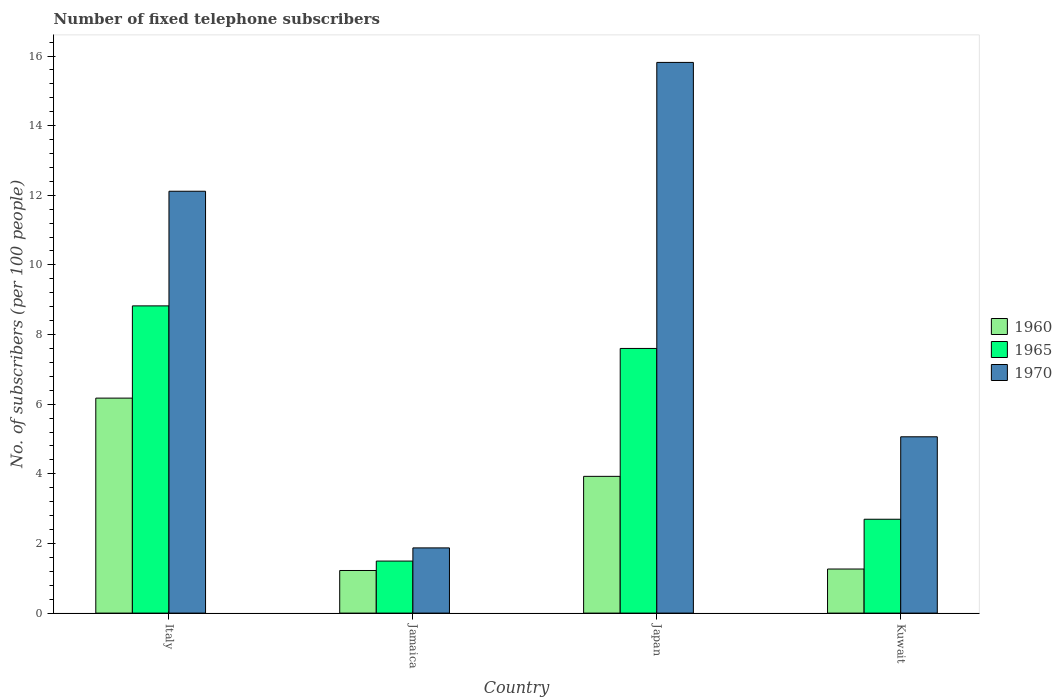How many different coloured bars are there?
Offer a very short reply. 3. How many groups of bars are there?
Give a very brief answer. 4. Are the number of bars per tick equal to the number of legend labels?
Offer a terse response. Yes. Are the number of bars on each tick of the X-axis equal?
Offer a terse response. Yes. How many bars are there on the 2nd tick from the right?
Offer a terse response. 3. What is the label of the 2nd group of bars from the left?
Make the answer very short. Jamaica. In how many cases, is the number of bars for a given country not equal to the number of legend labels?
Provide a succinct answer. 0. What is the number of fixed telephone subscribers in 1965 in Jamaica?
Keep it short and to the point. 1.49. Across all countries, what is the maximum number of fixed telephone subscribers in 1960?
Your answer should be compact. 6.17. Across all countries, what is the minimum number of fixed telephone subscribers in 1960?
Provide a succinct answer. 1.22. In which country was the number of fixed telephone subscribers in 1970 minimum?
Your response must be concise. Jamaica. What is the total number of fixed telephone subscribers in 1965 in the graph?
Offer a terse response. 20.61. What is the difference between the number of fixed telephone subscribers in 1970 in Jamaica and that in Kuwait?
Offer a very short reply. -3.19. What is the difference between the number of fixed telephone subscribers in 1965 in Kuwait and the number of fixed telephone subscribers in 1960 in Japan?
Make the answer very short. -1.23. What is the average number of fixed telephone subscribers in 1965 per country?
Your response must be concise. 5.15. What is the difference between the number of fixed telephone subscribers of/in 1960 and number of fixed telephone subscribers of/in 1965 in Jamaica?
Give a very brief answer. -0.27. In how many countries, is the number of fixed telephone subscribers in 1960 greater than 2.4?
Offer a terse response. 2. What is the ratio of the number of fixed telephone subscribers in 1965 in Italy to that in Jamaica?
Provide a succinct answer. 5.91. Is the number of fixed telephone subscribers in 1970 in Italy less than that in Kuwait?
Your response must be concise. No. What is the difference between the highest and the second highest number of fixed telephone subscribers in 1965?
Ensure brevity in your answer.  6.13. What is the difference between the highest and the lowest number of fixed telephone subscribers in 1970?
Your response must be concise. 13.94. In how many countries, is the number of fixed telephone subscribers in 1965 greater than the average number of fixed telephone subscribers in 1965 taken over all countries?
Ensure brevity in your answer.  2. Is the sum of the number of fixed telephone subscribers in 1965 in Jamaica and Kuwait greater than the maximum number of fixed telephone subscribers in 1970 across all countries?
Your answer should be very brief. No. What does the 3rd bar from the left in Jamaica represents?
Your answer should be compact. 1970. Is it the case that in every country, the sum of the number of fixed telephone subscribers in 1970 and number of fixed telephone subscribers in 1960 is greater than the number of fixed telephone subscribers in 1965?
Offer a very short reply. Yes. How many bars are there?
Make the answer very short. 12. How many countries are there in the graph?
Offer a very short reply. 4. What is the difference between two consecutive major ticks on the Y-axis?
Give a very brief answer. 2. Are the values on the major ticks of Y-axis written in scientific E-notation?
Provide a succinct answer. No. Does the graph contain any zero values?
Your answer should be very brief. No. How many legend labels are there?
Your answer should be very brief. 3. What is the title of the graph?
Your answer should be compact. Number of fixed telephone subscribers. Does "1960" appear as one of the legend labels in the graph?
Provide a succinct answer. Yes. What is the label or title of the X-axis?
Provide a short and direct response. Country. What is the label or title of the Y-axis?
Make the answer very short. No. of subscribers (per 100 people). What is the No. of subscribers (per 100 people) of 1960 in Italy?
Your answer should be very brief. 6.17. What is the No. of subscribers (per 100 people) of 1965 in Italy?
Offer a very short reply. 8.82. What is the No. of subscribers (per 100 people) in 1970 in Italy?
Your answer should be compact. 12.12. What is the No. of subscribers (per 100 people) of 1960 in Jamaica?
Offer a very short reply. 1.22. What is the No. of subscribers (per 100 people) of 1965 in Jamaica?
Keep it short and to the point. 1.49. What is the No. of subscribers (per 100 people) of 1970 in Jamaica?
Offer a very short reply. 1.87. What is the No. of subscribers (per 100 people) in 1960 in Japan?
Make the answer very short. 3.93. What is the No. of subscribers (per 100 people) of 1965 in Japan?
Offer a terse response. 7.6. What is the No. of subscribers (per 100 people) in 1970 in Japan?
Your response must be concise. 15.82. What is the No. of subscribers (per 100 people) in 1960 in Kuwait?
Keep it short and to the point. 1.27. What is the No. of subscribers (per 100 people) in 1965 in Kuwait?
Make the answer very short. 2.7. What is the No. of subscribers (per 100 people) in 1970 in Kuwait?
Provide a short and direct response. 5.06. Across all countries, what is the maximum No. of subscribers (per 100 people) in 1960?
Keep it short and to the point. 6.17. Across all countries, what is the maximum No. of subscribers (per 100 people) in 1965?
Your answer should be very brief. 8.82. Across all countries, what is the maximum No. of subscribers (per 100 people) in 1970?
Offer a terse response. 15.82. Across all countries, what is the minimum No. of subscribers (per 100 people) of 1960?
Provide a short and direct response. 1.22. Across all countries, what is the minimum No. of subscribers (per 100 people) of 1965?
Provide a succinct answer. 1.49. Across all countries, what is the minimum No. of subscribers (per 100 people) of 1970?
Provide a succinct answer. 1.87. What is the total No. of subscribers (per 100 people) in 1960 in the graph?
Ensure brevity in your answer.  12.59. What is the total No. of subscribers (per 100 people) of 1965 in the graph?
Give a very brief answer. 20.61. What is the total No. of subscribers (per 100 people) of 1970 in the graph?
Keep it short and to the point. 34.87. What is the difference between the No. of subscribers (per 100 people) in 1960 in Italy and that in Jamaica?
Offer a terse response. 4.95. What is the difference between the No. of subscribers (per 100 people) in 1965 in Italy and that in Jamaica?
Keep it short and to the point. 7.33. What is the difference between the No. of subscribers (per 100 people) in 1970 in Italy and that in Jamaica?
Offer a very short reply. 10.24. What is the difference between the No. of subscribers (per 100 people) in 1960 in Italy and that in Japan?
Provide a succinct answer. 2.25. What is the difference between the No. of subscribers (per 100 people) of 1965 in Italy and that in Japan?
Ensure brevity in your answer.  1.22. What is the difference between the No. of subscribers (per 100 people) of 1970 in Italy and that in Japan?
Offer a terse response. -3.7. What is the difference between the No. of subscribers (per 100 people) in 1960 in Italy and that in Kuwait?
Offer a very short reply. 4.91. What is the difference between the No. of subscribers (per 100 people) of 1965 in Italy and that in Kuwait?
Your response must be concise. 6.13. What is the difference between the No. of subscribers (per 100 people) in 1970 in Italy and that in Kuwait?
Your answer should be compact. 7.05. What is the difference between the No. of subscribers (per 100 people) in 1960 in Jamaica and that in Japan?
Ensure brevity in your answer.  -2.7. What is the difference between the No. of subscribers (per 100 people) of 1965 in Jamaica and that in Japan?
Give a very brief answer. -6.11. What is the difference between the No. of subscribers (per 100 people) in 1970 in Jamaica and that in Japan?
Your answer should be compact. -13.94. What is the difference between the No. of subscribers (per 100 people) of 1960 in Jamaica and that in Kuwait?
Your response must be concise. -0.04. What is the difference between the No. of subscribers (per 100 people) of 1965 in Jamaica and that in Kuwait?
Provide a short and direct response. -1.2. What is the difference between the No. of subscribers (per 100 people) in 1970 in Jamaica and that in Kuwait?
Give a very brief answer. -3.19. What is the difference between the No. of subscribers (per 100 people) of 1960 in Japan and that in Kuwait?
Keep it short and to the point. 2.66. What is the difference between the No. of subscribers (per 100 people) of 1965 in Japan and that in Kuwait?
Provide a succinct answer. 4.91. What is the difference between the No. of subscribers (per 100 people) of 1970 in Japan and that in Kuwait?
Your answer should be compact. 10.75. What is the difference between the No. of subscribers (per 100 people) of 1960 in Italy and the No. of subscribers (per 100 people) of 1965 in Jamaica?
Keep it short and to the point. 4.68. What is the difference between the No. of subscribers (per 100 people) in 1960 in Italy and the No. of subscribers (per 100 people) in 1970 in Jamaica?
Provide a short and direct response. 4.3. What is the difference between the No. of subscribers (per 100 people) in 1965 in Italy and the No. of subscribers (per 100 people) in 1970 in Jamaica?
Your answer should be very brief. 6.95. What is the difference between the No. of subscribers (per 100 people) of 1960 in Italy and the No. of subscribers (per 100 people) of 1965 in Japan?
Your answer should be compact. -1.43. What is the difference between the No. of subscribers (per 100 people) in 1960 in Italy and the No. of subscribers (per 100 people) in 1970 in Japan?
Your answer should be compact. -9.64. What is the difference between the No. of subscribers (per 100 people) in 1965 in Italy and the No. of subscribers (per 100 people) in 1970 in Japan?
Keep it short and to the point. -6.99. What is the difference between the No. of subscribers (per 100 people) in 1960 in Italy and the No. of subscribers (per 100 people) in 1965 in Kuwait?
Ensure brevity in your answer.  3.48. What is the difference between the No. of subscribers (per 100 people) in 1960 in Italy and the No. of subscribers (per 100 people) in 1970 in Kuwait?
Provide a short and direct response. 1.11. What is the difference between the No. of subscribers (per 100 people) of 1965 in Italy and the No. of subscribers (per 100 people) of 1970 in Kuwait?
Your answer should be very brief. 3.76. What is the difference between the No. of subscribers (per 100 people) of 1960 in Jamaica and the No. of subscribers (per 100 people) of 1965 in Japan?
Your response must be concise. -6.38. What is the difference between the No. of subscribers (per 100 people) in 1960 in Jamaica and the No. of subscribers (per 100 people) in 1970 in Japan?
Offer a very short reply. -14.59. What is the difference between the No. of subscribers (per 100 people) of 1965 in Jamaica and the No. of subscribers (per 100 people) of 1970 in Japan?
Your answer should be very brief. -14.32. What is the difference between the No. of subscribers (per 100 people) in 1960 in Jamaica and the No. of subscribers (per 100 people) in 1965 in Kuwait?
Give a very brief answer. -1.47. What is the difference between the No. of subscribers (per 100 people) of 1960 in Jamaica and the No. of subscribers (per 100 people) of 1970 in Kuwait?
Your answer should be very brief. -3.84. What is the difference between the No. of subscribers (per 100 people) of 1965 in Jamaica and the No. of subscribers (per 100 people) of 1970 in Kuwait?
Keep it short and to the point. -3.57. What is the difference between the No. of subscribers (per 100 people) of 1960 in Japan and the No. of subscribers (per 100 people) of 1965 in Kuwait?
Offer a terse response. 1.23. What is the difference between the No. of subscribers (per 100 people) in 1960 in Japan and the No. of subscribers (per 100 people) in 1970 in Kuwait?
Provide a short and direct response. -1.14. What is the difference between the No. of subscribers (per 100 people) of 1965 in Japan and the No. of subscribers (per 100 people) of 1970 in Kuwait?
Your answer should be very brief. 2.54. What is the average No. of subscribers (per 100 people) in 1960 per country?
Ensure brevity in your answer.  3.15. What is the average No. of subscribers (per 100 people) in 1965 per country?
Your response must be concise. 5.15. What is the average No. of subscribers (per 100 people) in 1970 per country?
Ensure brevity in your answer.  8.72. What is the difference between the No. of subscribers (per 100 people) in 1960 and No. of subscribers (per 100 people) in 1965 in Italy?
Offer a very short reply. -2.65. What is the difference between the No. of subscribers (per 100 people) in 1960 and No. of subscribers (per 100 people) in 1970 in Italy?
Your answer should be very brief. -5.94. What is the difference between the No. of subscribers (per 100 people) of 1965 and No. of subscribers (per 100 people) of 1970 in Italy?
Keep it short and to the point. -3.29. What is the difference between the No. of subscribers (per 100 people) of 1960 and No. of subscribers (per 100 people) of 1965 in Jamaica?
Give a very brief answer. -0.27. What is the difference between the No. of subscribers (per 100 people) of 1960 and No. of subscribers (per 100 people) of 1970 in Jamaica?
Offer a very short reply. -0.65. What is the difference between the No. of subscribers (per 100 people) of 1965 and No. of subscribers (per 100 people) of 1970 in Jamaica?
Offer a terse response. -0.38. What is the difference between the No. of subscribers (per 100 people) of 1960 and No. of subscribers (per 100 people) of 1965 in Japan?
Your answer should be compact. -3.67. What is the difference between the No. of subscribers (per 100 people) in 1960 and No. of subscribers (per 100 people) in 1970 in Japan?
Keep it short and to the point. -11.89. What is the difference between the No. of subscribers (per 100 people) in 1965 and No. of subscribers (per 100 people) in 1970 in Japan?
Your answer should be very brief. -8.22. What is the difference between the No. of subscribers (per 100 people) in 1960 and No. of subscribers (per 100 people) in 1965 in Kuwait?
Ensure brevity in your answer.  -1.43. What is the difference between the No. of subscribers (per 100 people) of 1960 and No. of subscribers (per 100 people) of 1970 in Kuwait?
Provide a succinct answer. -3.8. What is the difference between the No. of subscribers (per 100 people) in 1965 and No. of subscribers (per 100 people) in 1970 in Kuwait?
Provide a short and direct response. -2.37. What is the ratio of the No. of subscribers (per 100 people) in 1960 in Italy to that in Jamaica?
Make the answer very short. 5.05. What is the ratio of the No. of subscribers (per 100 people) in 1965 in Italy to that in Jamaica?
Make the answer very short. 5.91. What is the ratio of the No. of subscribers (per 100 people) of 1970 in Italy to that in Jamaica?
Provide a succinct answer. 6.47. What is the ratio of the No. of subscribers (per 100 people) in 1960 in Italy to that in Japan?
Give a very brief answer. 1.57. What is the ratio of the No. of subscribers (per 100 people) in 1965 in Italy to that in Japan?
Provide a succinct answer. 1.16. What is the ratio of the No. of subscribers (per 100 people) of 1970 in Italy to that in Japan?
Your answer should be very brief. 0.77. What is the ratio of the No. of subscribers (per 100 people) of 1960 in Italy to that in Kuwait?
Your answer should be compact. 4.88. What is the ratio of the No. of subscribers (per 100 people) in 1965 in Italy to that in Kuwait?
Your response must be concise. 3.27. What is the ratio of the No. of subscribers (per 100 people) in 1970 in Italy to that in Kuwait?
Provide a short and direct response. 2.39. What is the ratio of the No. of subscribers (per 100 people) of 1960 in Jamaica to that in Japan?
Offer a terse response. 0.31. What is the ratio of the No. of subscribers (per 100 people) of 1965 in Jamaica to that in Japan?
Provide a succinct answer. 0.2. What is the ratio of the No. of subscribers (per 100 people) in 1970 in Jamaica to that in Japan?
Your answer should be very brief. 0.12. What is the ratio of the No. of subscribers (per 100 people) in 1960 in Jamaica to that in Kuwait?
Provide a succinct answer. 0.97. What is the ratio of the No. of subscribers (per 100 people) of 1965 in Jamaica to that in Kuwait?
Provide a succinct answer. 0.55. What is the ratio of the No. of subscribers (per 100 people) of 1970 in Jamaica to that in Kuwait?
Give a very brief answer. 0.37. What is the ratio of the No. of subscribers (per 100 people) in 1960 in Japan to that in Kuwait?
Offer a very short reply. 3.1. What is the ratio of the No. of subscribers (per 100 people) in 1965 in Japan to that in Kuwait?
Ensure brevity in your answer.  2.82. What is the ratio of the No. of subscribers (per 100 people) in 1970 in Japan to that in Kuwait?
Keep it short and to the point. 3.12. What is the difference between the highest and the second highest No. of subscribers (per 100 people) in 1960?
Offer a very short reply. 2.25. What is the difference between the highest and the second highest No. of subscribers (per 100 people) in 1965?
Your response must be concise. 1.22. What is the difference between the highest and the second highest No. of subscribers (per 100 people) of 1970?
Make the answer very short. 3.7. What is the difference between the highest and the lowest No. of subscribers (per 100 people) of 1960?
Offer a very short reply. 4.95. What is the difference between the highest and the lowest No. of subscribers (per 100 people) in 1965?
Offer a very short reply. 7.33. What is the difference between the highest and the lowest No. of subscribers (per 100 people) of 1970?
Keep it short and to the point. 13.94. 